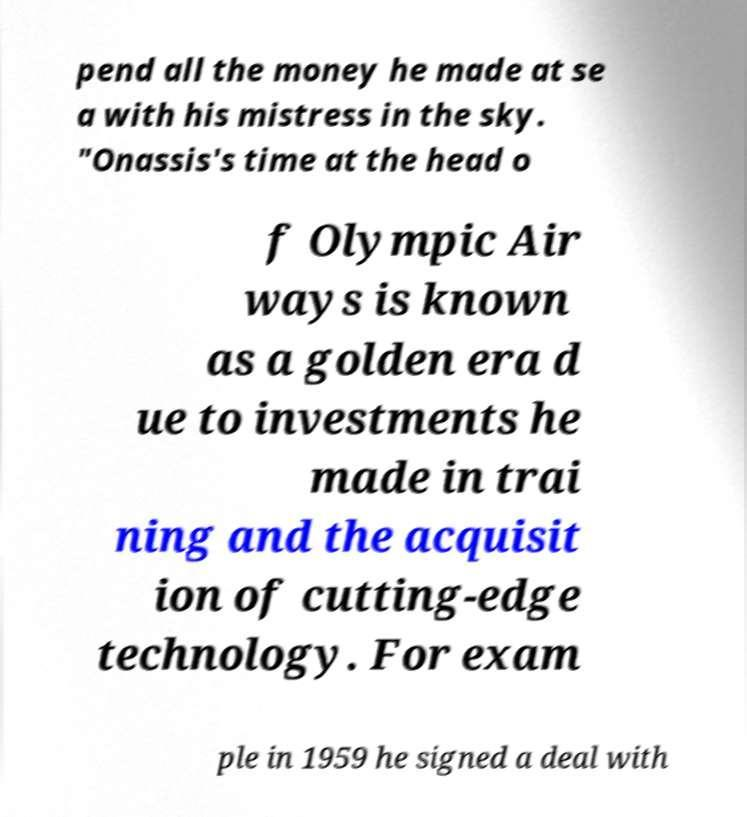Please read and relay the text visible in this image. What does it say? pend all the money he made at se a with his mistress in the sky. "Onassis's time at the head o f Olympic Air ways is known as a golden era d ue to investments he made in trai ning and the acquisit ion of cutting-edge technology. For exam ple in 1959 he signed a deal with 